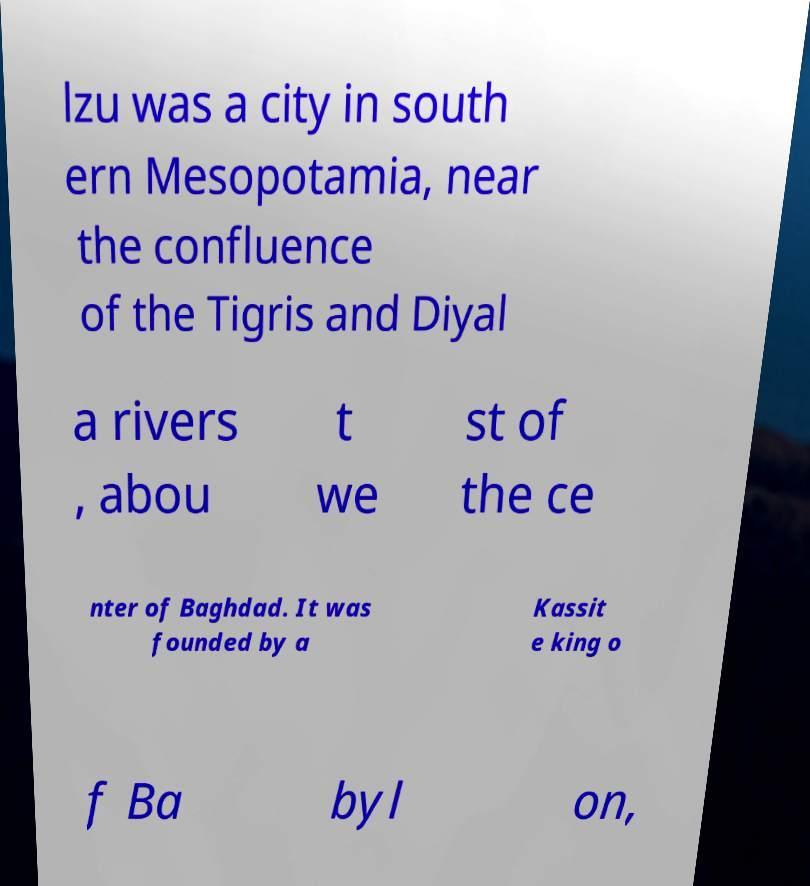What messages or text are displayed in this image? I need them in a readable, typed format. lzu was a city in south ern Mesopotamia, near the confluence of the Tigris and Diyal a rivers , abou t we st of the ce nter of Baghdad. It was founded by a Kassit e king o f Ba byl on, 